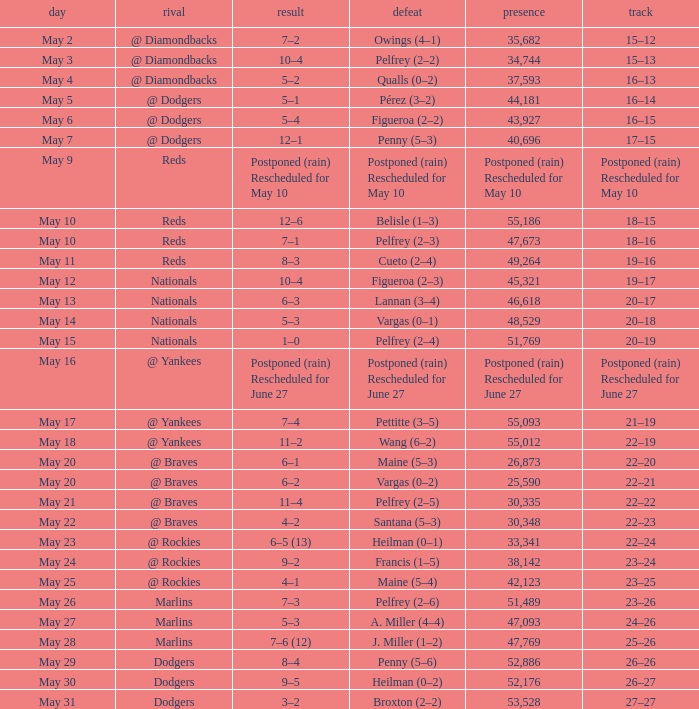Loss of postponed (rain) rescheduled for may 10 had what record? Postponed (rain) Rescheduled for May 10. 